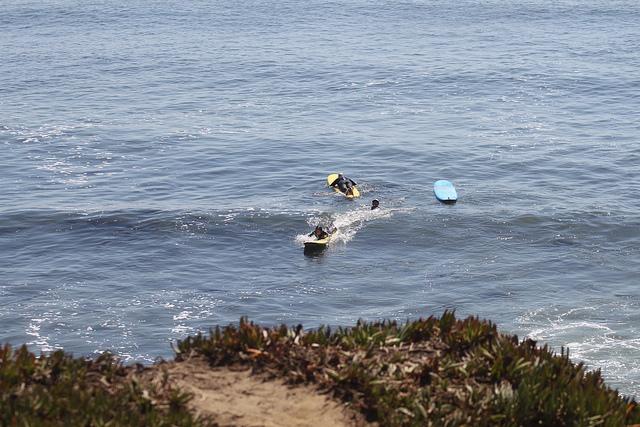Why is the board empty?
Keep it brief. Person is in water. What color is the water?
Write a very short answer. Blue. How many people can be seen?
Short answer required. 3. Is the board right side up?
Short answer required. Yes. 